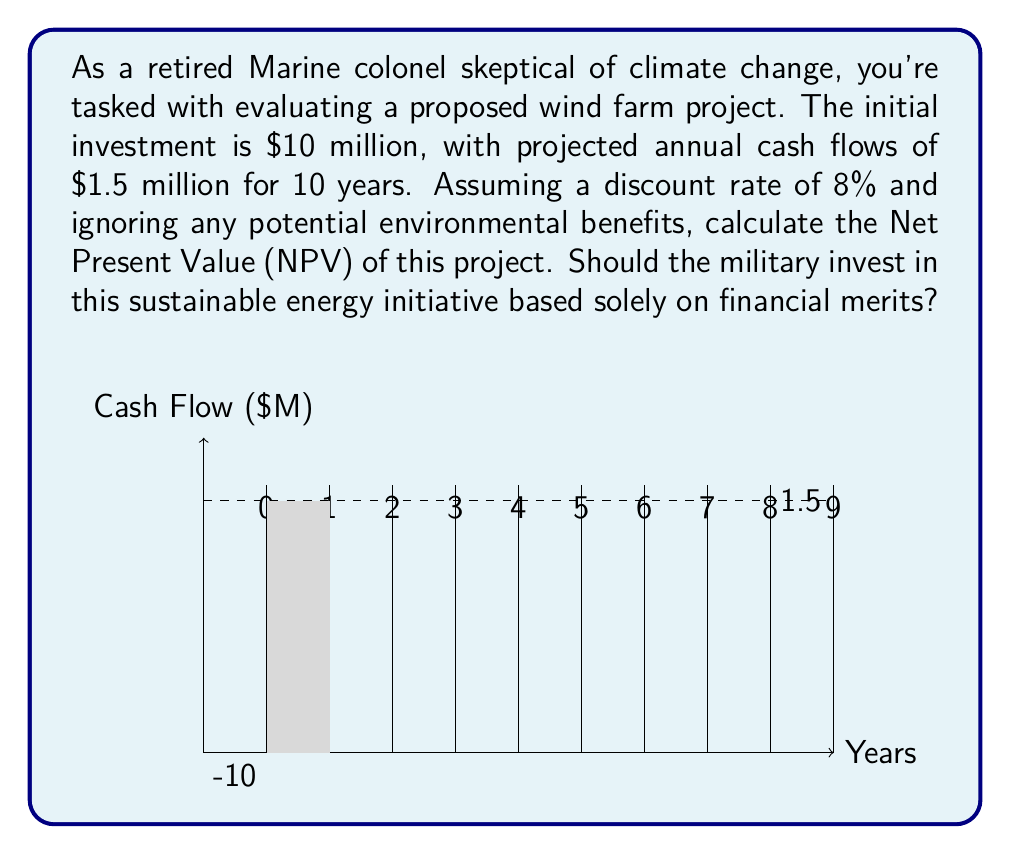Help me with this question. To calculate the Net Present Value (NPV) of this sustainable energy project, we'll follow these steps:

1) The NPV formula is:

   $$NPV = -C_0 + \sum_{t=1}^{n} \frac{C_t}{(1+r)^t}$$

   Where:
   $C_0$ is the initial investment
   $C_t$ is the cash flow at time t
   $r$ is the discount rate
   $n$ is the number of periods

2) Given:
   - Initial investment ($C_0$) = $10 million
   - Annual cash flow ($C_t$) = $1.5 million
   - Discount rate ($r$) = 8% = 0.08
   - Number of periods ($n$) = 10 years

3) Let's calculate the present value of each year's cash flow:

   Year 1: $\frac{1.5}{(1+0.08)^1} = 1.3889$ million
   Year 2: $\frac{1.5}{(1+0.08)^2} = 1.2860$ million
   ...
   Year 10: $\frac{1.5}{(1+0.08)^{10}} = 0.6944$ million

4) Sum up all these present values:

   $\sum_{t=1}^{10} \frac{1.5}{(1+0.08)^t} = 10.0615$ million

5) Now, apply the NPV formula:

   $NPV = -10 + 10.0615 = 0.0615$ million

6) The NPV is positive, which means the project is financially viable based solely on monetary considerations, regardless of environmental impact.
Answer: $61,500 (NPV is positive, invest) 